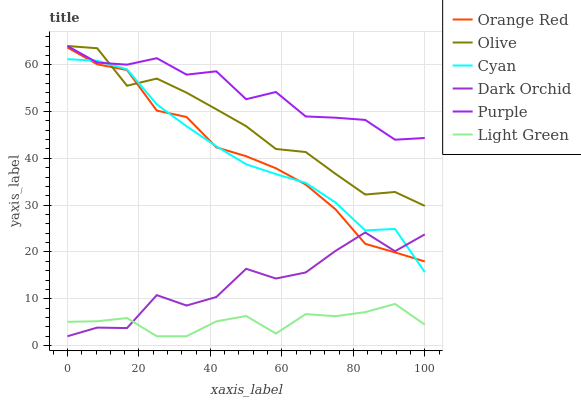Does Light Green have the minimum area under the curve?
Answer yes or no. Yes. Does Purple have the maximum area under the curve?
Answer yes or no. Yes. Does Dark Orchid have the minimum area under the curve?
Answer yes or no. No. Does Dark Orchid have the maximum area under the curve?
Answer yes or no. No. Is Cyan the smoothest?
Answer yes or no. Yes. Is Dark Orchid the roughest?
Answer yes or no. Yes. Is Light Green the smoothest?
Answer yes or no. No. Is Light Green the roughest?
Answer yes or no. No. Does Dark Orchid have the lowest value?
Answer yes or no. Yes. Does Olive have the lowest value?
Answer yes or no. No. Does Olive have the highest value?
Answer yes or no. Yes. Does Dark Orchid have the highest value?
Answer yes or no. No. Is Light Green less than Cyan?
Answer yes or no. Yes. Is Olive greater than Light Green?
Answer yes or no. Yes. Does Orange Red intersect Cyan?
Answer yes or no. Yes. Is Orange Red less than Cyan?
Answer yes or no. No. Is Orange Red greater than Cyan?
Answer yes or no. No. Does Light Green intersect Cyan?
Answer yes or no. No. 